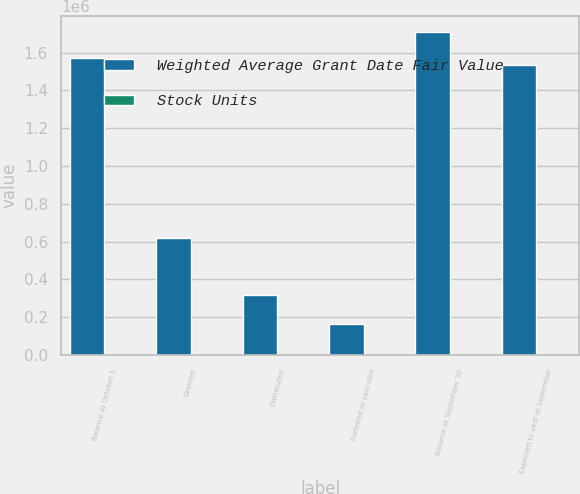Convert chart to OTSL. <chart><loc_0><loc_0><loc_500><loc_500><stacked_bar_chart><ecel><fcel>Balance at October 1<fcel>Granted<fcel>Distributed<fcel>Forfeited or canceled<fcel>Balance at September 30<fcel>Expected to vest at September<nl><fcel>Weighted Average Grant Date Fair Value<fcel>1.57033e+06<fcel>618679<fcel>316839<fcel>165211<fcel>1.70696e+06<fcel>1.53626e+06<nl><fcel>Stock Units<fcel>69.35<fcel>62.96<fcel>60.32<fcel>62.58<fcel>69.36<fcel>69.36<nl></chart> 